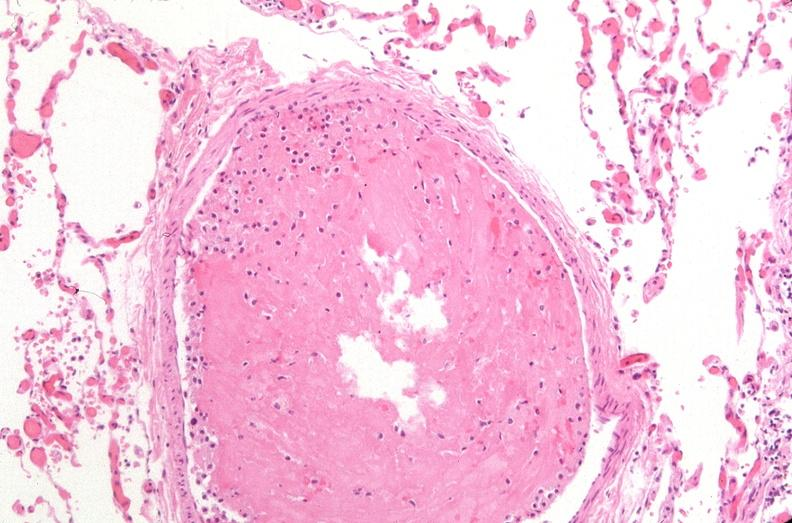does newborn cord around neck show lung, organizing thromboembolus?
Answer the question using a single word or phrase. No 